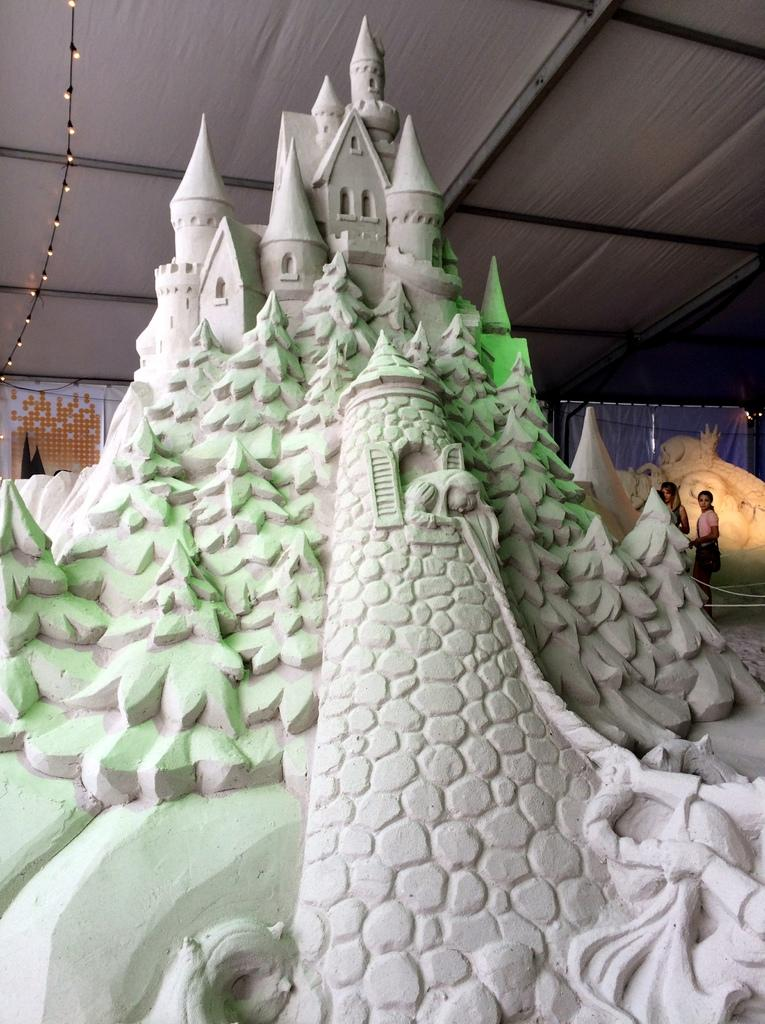What is the main subject of the image? There is a sculpture of Disney World in the image. Are there any people present in the image? Yes, there are two people behind the sculpture. Can you describe any additional features in the image? There is a wire attached to the roof with small lights. What type of leaf is falling from the mist in the image? There is no mist or leaf present in the image. 